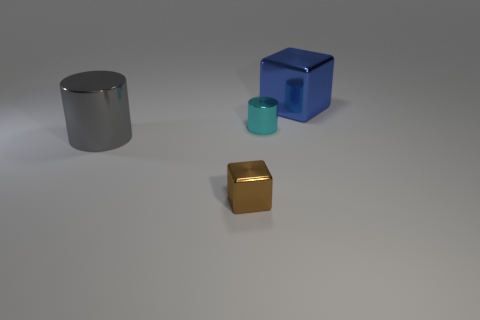There is a shiny thing that is on the right side of the cyan metallic thing; is it the same shape as the big shiny thing on the left side of the blue metal object?
Offer a very short reply. No. There is another large thing that is the same shape as the brown thing; what material is it?
Keep it short and to the point. Metal. What number of cylinders are shiny things or large blue objects?
Your response must be concise. 2. What number of large cylinders are made of the same material as the cyan object?
Give a very brief answer. 1. Is the block that is to the left of the blue object made of the same material as the big object in front of the large metallic cube?
Make the answer very short. Yes. There is a big metallic thing to the left of the shiny cylinder that is on the right side of the small brown metallic object; what number of cyan metallic objects are left of it?
Provide a short and direct response. 0. Does the tiny metal thing that is in front of the cyan metal thing have the same color as the shiny cube behind the cyan cylinder?
Offer a terse response. No. Is there any other thing of the same color as the tiny shiny cube?
Make the answer very short. No. There is a metallic thing that is to the left of the small brown cube that is in front of the cyan metal thing; what is its color?
Ensure brevity in your answer.  Gray. Is there a large gray metal cylinder?
Offer a very short reply. Yes. 